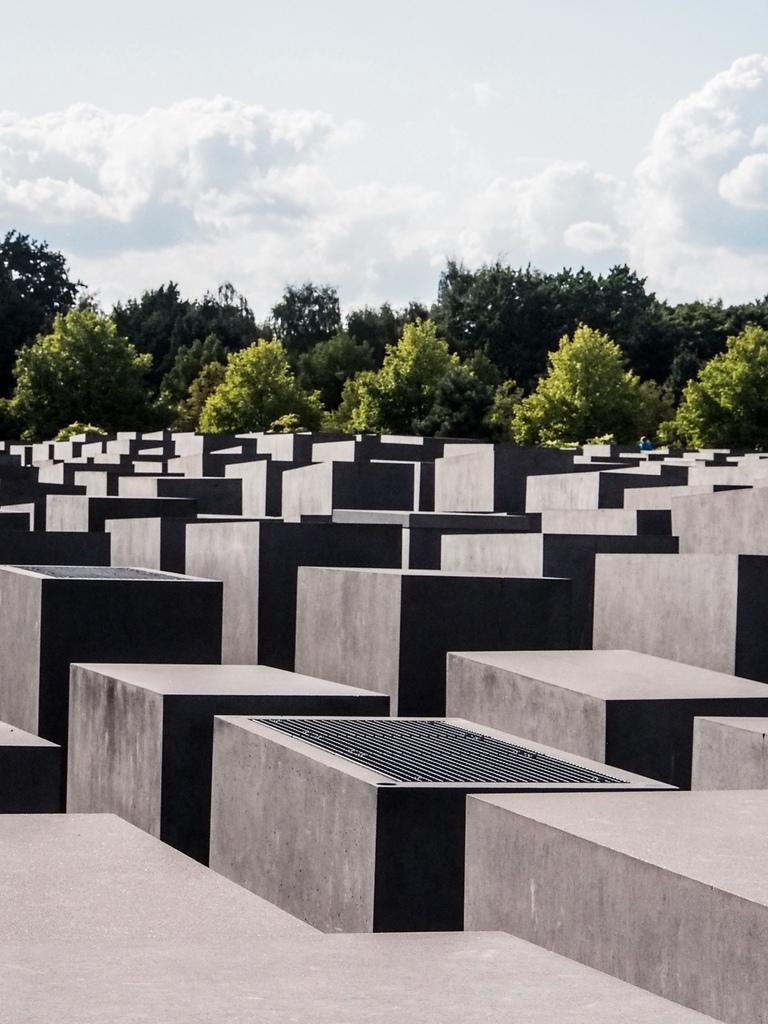What type of material is present in the image? There are bricks in the image. What natural elements can be seen in the image? There are trees in the image. What disease is being offered by the partner in the image? There is no partner or disease present in the image; it only features bricks and trees. 